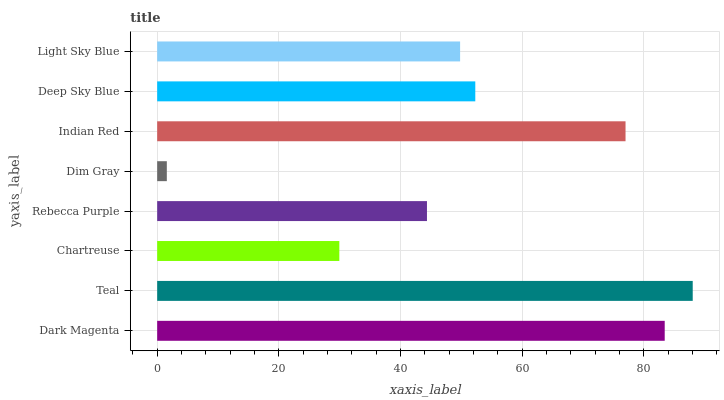Is Dim Gray the minimum?
Answer yes or no. Yes. Is Teal the maximum?
Answer yes or no. Yes. Is Chartreuse the minimum?
Answer yes or no. No. Is Chartreuse the maximum?
Answer yes or no. No. Is Teal greater than Chartreuse?
Answer yes or no. Yes. Is Chartreuse less than Teal?
Answer yes or no. Yes. Is Chartreuse greater than Teal?
Answer yes or no. No. Is Teal less than Chartreuse?
Answer yes or no. No. Is Deep Sky Blue the high median?
Answer yes or no. Yes. Is Light Sky Blue the low median?
Answer yes or no. Yes. Is Light Sky Blue the high median?
Answer yes or no. No. Is Chartreuse the low median?
Answer yes or no. No. 